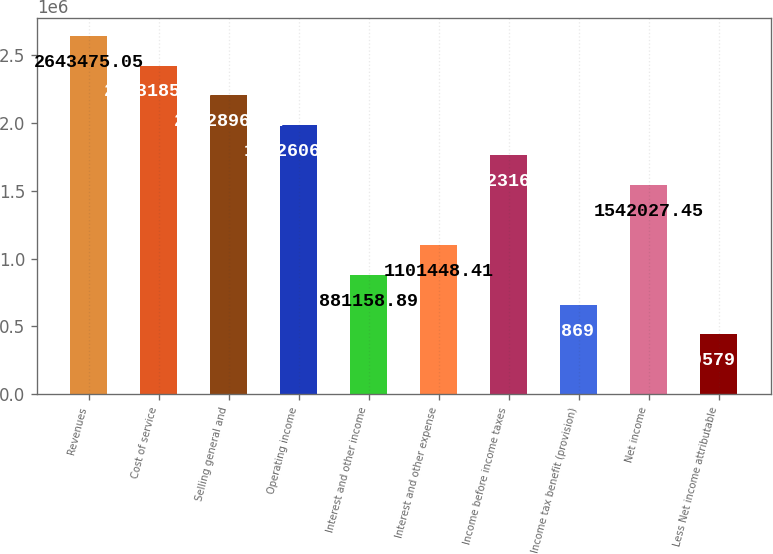<chart> <loc_0><loc_0><loc_500><loc_500><bar_chart><fcel>Revenues<fcel>Cost of service<fcel>Selling general and<fcel>Operating income<fcel>Interest and other income<fcel>Interest and other expense<fcel>Income before income taxes<fcel>Income tax benefit (provision)<fcel>Net income<fcel>Less Net income attributable<nl><fcel>2.64348e+06<fcel>2.42319e+06<fcel>2.2029e+06<fcel>1.98261e+06<fcel>881159<fcel>1.10145e+06<fcel>1.76232e+06<fcel>660869<fcel>1.54203e+06<fcel>440580<nl></chart> 